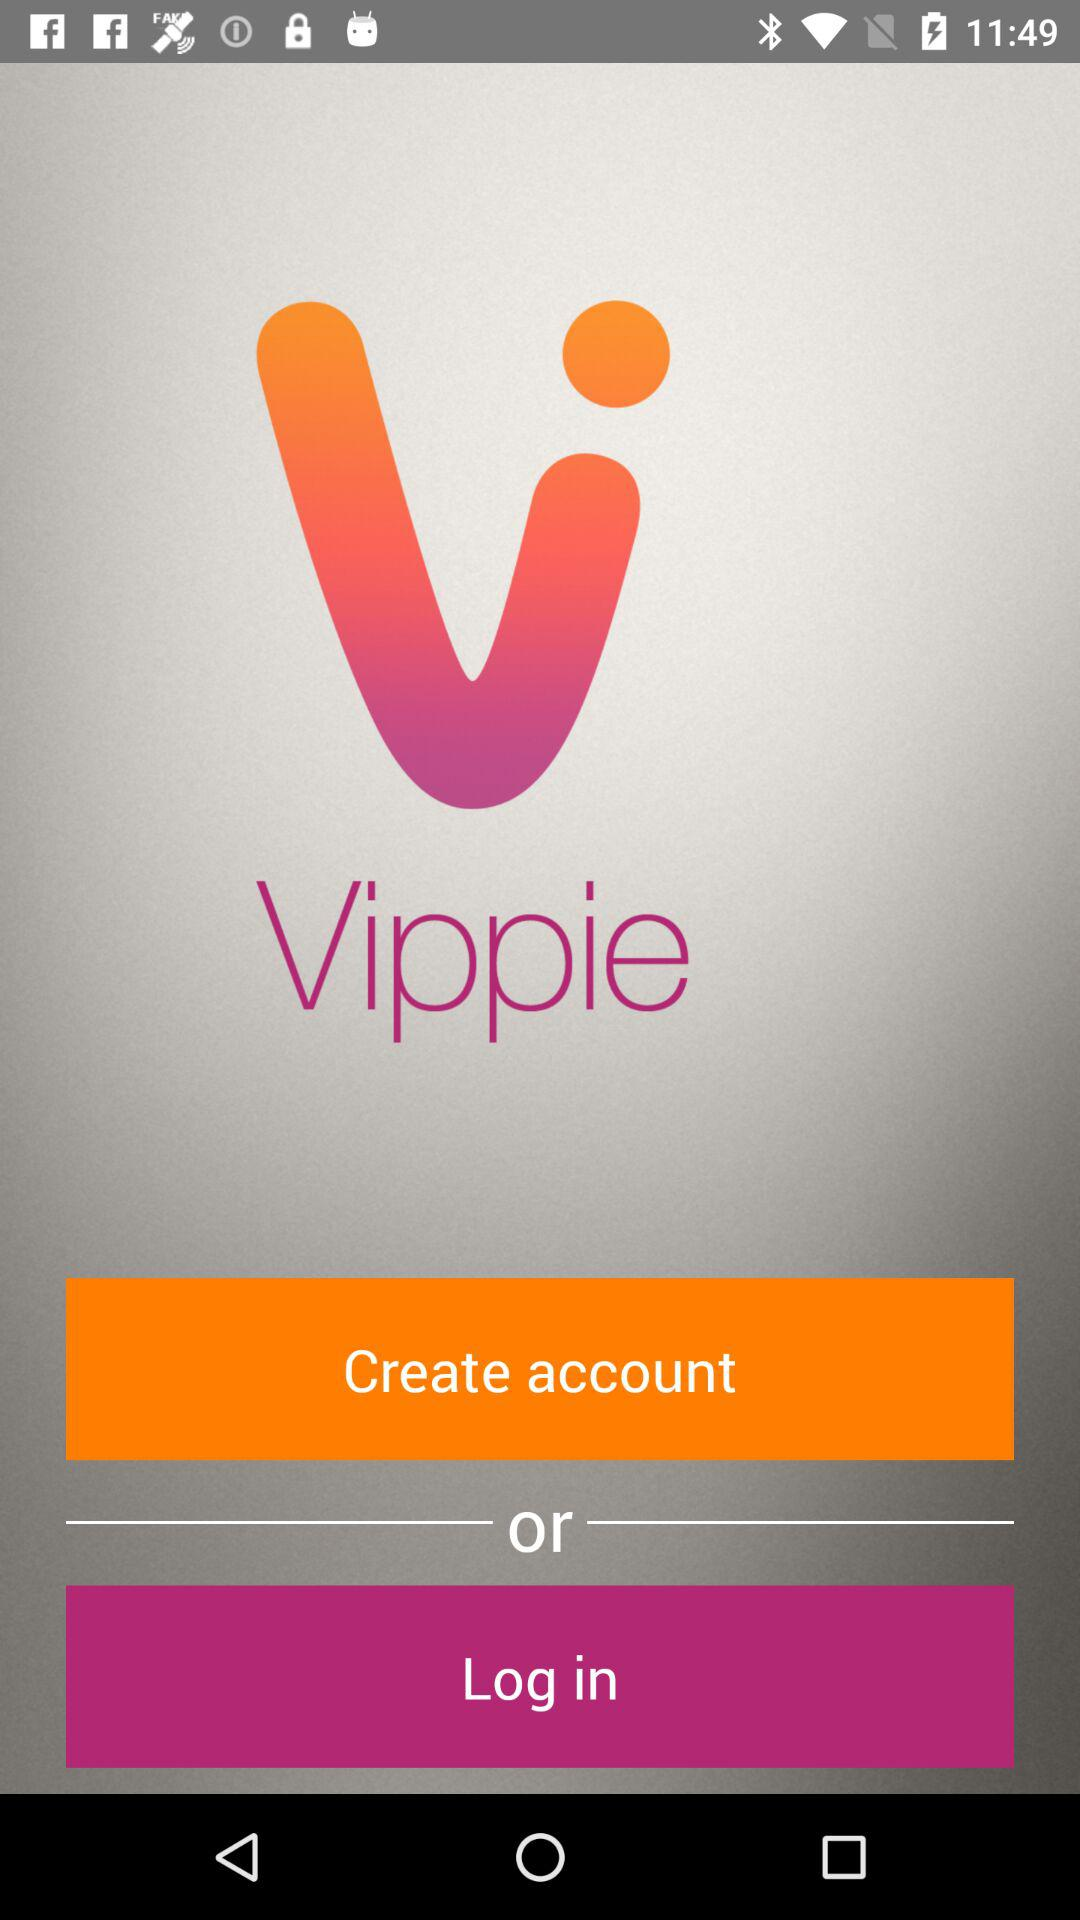Who is logging into their account?
When the provided information is insufficient, respond with <no answer>. <no answer> 